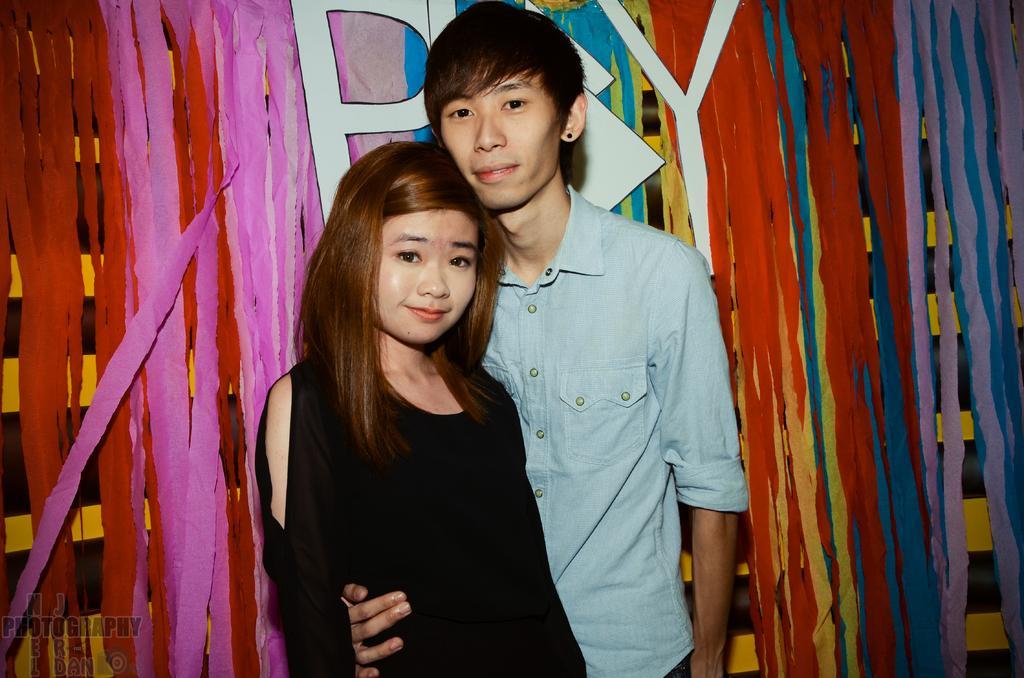Describe this image in one or two sentences. In this picture I can see a man and a woman standing, and in the background there is a board, there are paper ribbons and there is a watermark on the image. 